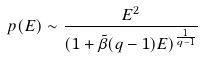Convert formula to latex. <formula><loc_0><loc_0><loc_500><loc_500>p ( E ) \sim \frac { E ^ { 2 } } { ( 1 + \tilde { \beta } ( q - 1 ) E ) ^ { \frac { 1 } { q - 1 } } }</formula> 